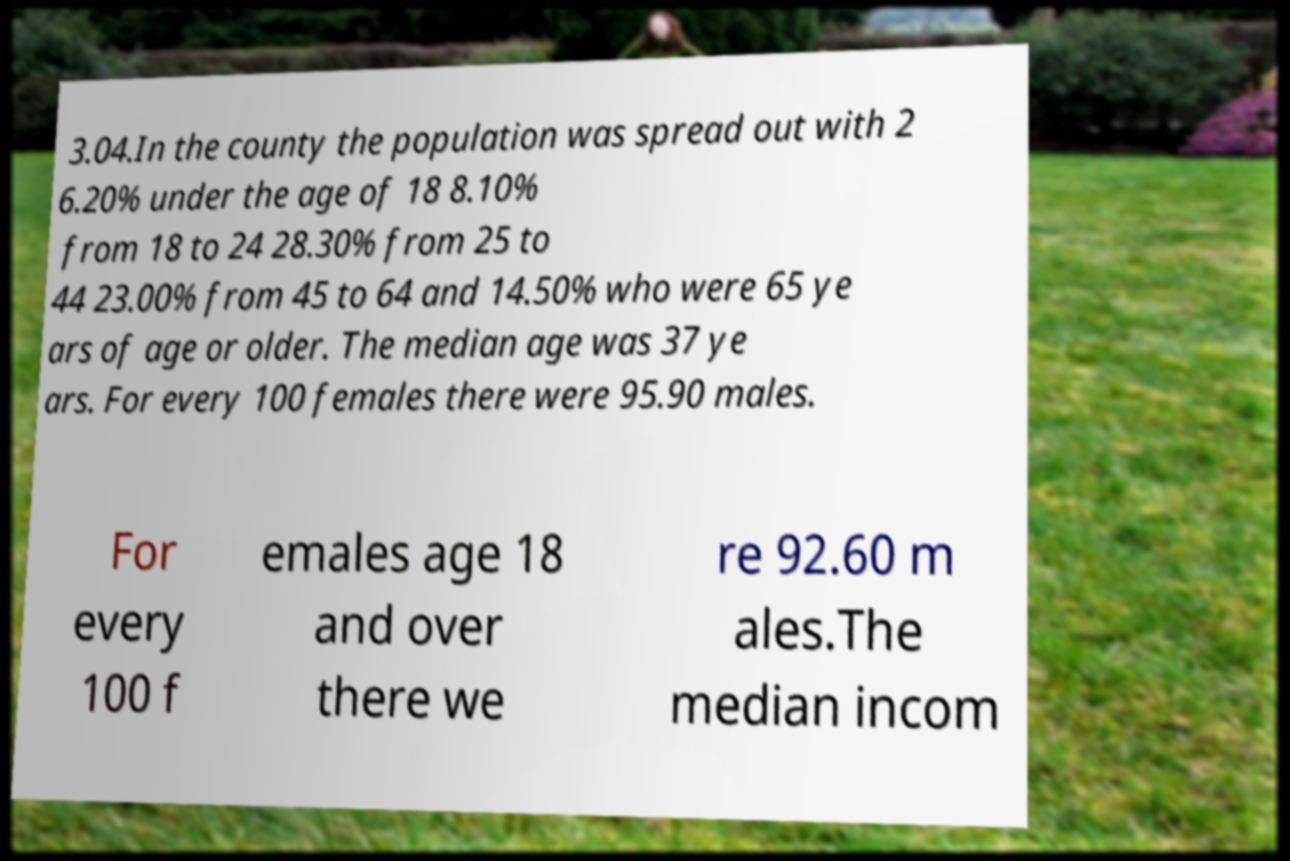Can you accurately transcribe the text from the provided image for me? 3.04.In the county the population was spread out with 2 6.20% under the age of 18 8.10% from 18 to 24 28.30% from 25 to 44 23.00% from 45 to 64 and 14.50% who were 65 ye ars of age or older. The median age was 37 ye ars. For every 100 females there were 95.90 males. For every 100 f emales age 18 and over there we re 92.60 m ales.The median incom 